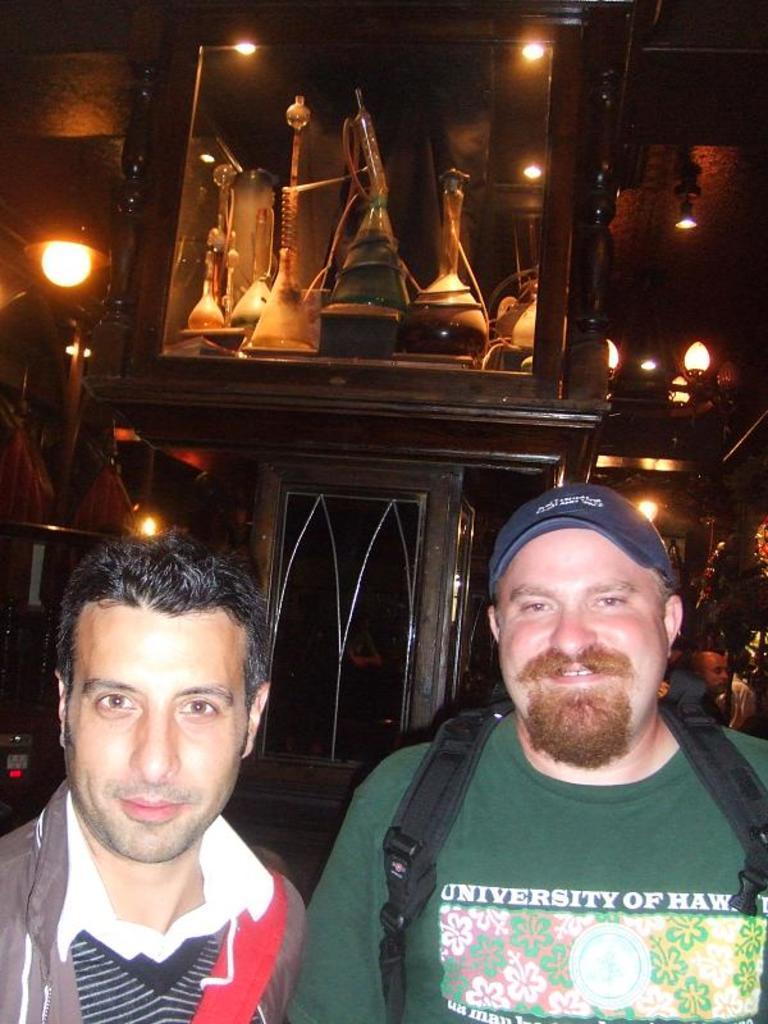Describe this image in one or two sentences. This image consists of two men. To the right, the man is wearing green T-shirt. In the background, there is a box in which there are hookah pots kept. And there are lights. 